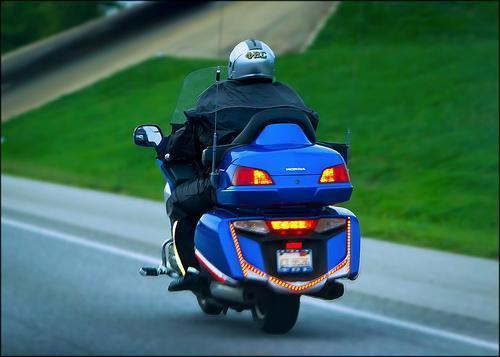How many motorcycles are in the photo?
Give a very brief answer. 1. 